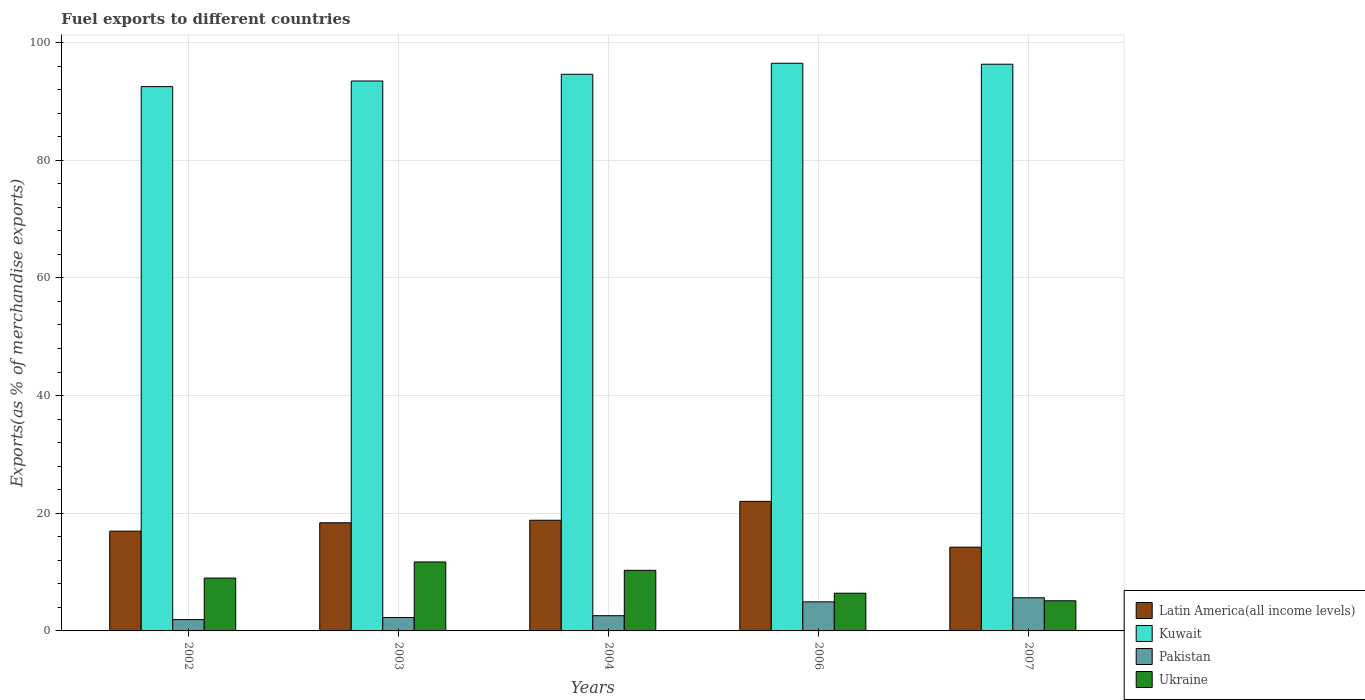How many groups of bars are there?
Make the answer very short. 5. How many bars are there on the 1st tick from the left?
Offer a very short reply. 4. How many bars are there on the 1st tick from the right?
Provide a short and direct response. 4. What is the percentage of exports to different countries in Ukraine in 2002?
Your answer should be very brief. 8.98. Across all years, what is the maximum percentage of exports to different countries in Latin America(all income levels)?
Offer a very short reply. 22.02. Across all years, what is the minimum percentage of exports to different countries in Pakistan?
Give a very brief answer. 1.93. In which year was the percentage of exports to different countries in Ukraine maximum?
Provide a short and direct response. 2003. In which year was the percentage of exports to different countries in Pakistan minimum?
Keep it short and to the point. 2002. What is the total percentage of exports to different countries in Pakistan in the graph?
Provide a short and direct response. 17.36. What is the difference between the percentage of exports to different countries in Latin America(all income levels) in 2004 and that in 2007?
Make the answer very short. 4.58. What is the difference between the percentage of exports to different countries in Latin America(all income levels) in 2007 and the percentage of exports to different countries in Ukraine in 2004?
Your answer should be very brief. 3.93. What is the average percentage of exports to different countries in Ukraine per year?
Provide a short and direct response. 8.51. In the year 2002, what is the difference between the percentage of exports to different countries in Latin America(all income levels) and percentage of exports to different countries in Kuwait?
Give a very brief answer. -75.54. In how many years, is the percentage of exports to different countries in Ukraine greater than 16 %?
Your answer should be compact. 0. What is the ratio of the percentage of exports to different countries in Latin America(all income levels) in 2002 to that in 2007?
Give a very brief answer. 1.19. Is the percentage of exports to different countries in Ukraine in 2004 less than that in 2007?
Offer a very short reply. No. What is the difference between the highest and the second highest percentage of exports to different countries in Ukraine?
Keep it short and to the point. 1.42. What is the difference between the highest and the lowest percentage of exports to different countries in Ukraine?
Your response must be concise. 6.6. In how many years, is the percentage of exports to different countries in Kuwait greater than the average percentage of exports to different countries in Kuwait taken over all years?
Your response must be concise. 2. Is the sum of the percentage of exports to different countries in Ukraine in 2003 and 2004 greater than the maximum percentage of exports to different countries in Pakistan across all years?
Your answer should be very brief. Yes. Is it the case that in every year, the sum of the percentage of exports to different countries in Latin America(all income levels) and percentage of exports to different countries in Kuwait is greater than the sum of percentage of exports to different countries in Ukraine and percentage of exports to different countries in Pakistan?
Your answer should be very brief. No. What does the 1st bar from the right in 2002 represents?
Your answer should be compact. Ukraine. Is it the case that in every year, the sum of the percentage of exports to different countries in Pakistan and percentage of exports to different countries in Ukraine is greater than the percentage of exports to different countries in Kuwait?
Offer a very short reply. No. Are all the bars in the graph horizontal?
Offer a terse response. No. What is the title of the graph?
Give a very brief answer. Fuel exports to different countries. Does "Gambia, The" appear as one of the legend labels in the graph?
Offer a very short reply. No. What is the label or title of the Y-axis?
Offer a very short reply. Exports(as % of merchandise exports). What is the Exports(as % of merchandise exports) in Latin America(all income levels) in 2002?
Give a very brief answer. 16.95. What is the Exports(as % of merchandise exports) of Kuwait in 2002?
Give a very brief answer. 92.5. What is the Exports(as % of merchandise exports) of Pakistan in 2002?
Your answer should be compact. 1.93. What is the Exports(as % of merchandise exports) of Ukraine in 2002?
Your answer should be very brief. 8.98. What is the Exports(as % of merchandise exports) in Latin America(all income levels) in 2003?
Ensure brevity in your answer.  18.38. What is the Exports(as % of merchandise exports) of Kuwait in 2003?
Give a very brief answer. 93.46. What is the Exports(as % of merchandise exports) of Pakistan in 2003?
Offer a terse response. 2.28. What is the Exports(as % of merchandise exports) of Ukraine in 2003?
Offer a terse response. 11.72. What is the Exports(as % of merchandise exports) of Latin America(all income levels) in 2004?
Keep it short and to the point. 18.81. What is the Exports(as % of merchandise exports) in Kuwait in 2004?
Give a very brief answer. 94.6. What is the Exports(as % of merchandise exports) of Pakistan in 2004?
Make the answer very short. 2.59. What is the Exports(as % of merchandise exports) in Ukraine in 2004?
Your answer should be very brief. 10.3. What is the Exports(as % of merchandise exports) of Latin America(all income levels) in 2006?
Your answer should be compact. 22.02. What is the Exports(as % of merchandise exports) in Kuwait in 2006?
Your response must be concise. 96.47. What is the Exports(as % of merchandise exports) of Pakistan in 2006?
Offer a terse response. 4.94. What is the Exports(as % of merchandise exports) of Ukraine in 2006?
Keep it short and to the point. 6.41. What is the Exports(as % of merchandise exports) in Latin America(all income levels) in 2007?
Give a very brief answer. 14.23. What is the Exports(as % of merchandise exports) of Kuwait in 2007?
Your answer should be very brief. 96.31. What is the Exports(as % of merchandise exports) of Pakistan in 2007?
Ensure brevity in your answer.  5.63. What is the Exports(as % of merchandise exports) of Ukraine in 2007?
Ensure brevity in your answer.  5.12. Across all years, what is the maximum Exports(as % of merchandise exports) in Latin America(all income levels)?
Ensure brevity in your answer.  22.02. Across all years, what is the maximum Exports(as % of merchandise exports) of Kuwait?
Your response must be concise. 96.47. Across all years, what is the maximum Exports(as % of merchandise exports) of Pakistan?
Offer a terse response. 5.63. Across all years, what is the maximum Exports(as % of merchandise exports) of Ukraine?
Your response must be concise. 11.72. Across all years, what is the minimum Exports(as % of merchandise exports) in Latin America(all income levels)?
Keep it short and to the point. 14.23. Across all years, what is the minimum Exports(as % of merchandise exports) of Kuwait?
Offer a terse response. 92.5. Across all years, what is the minimum Exports(as % of merchandise exports) of Pakistan?
Keep it short and to the point. 1.93. Across all years, what is the minimum Exports(as % of merchandise exports) of Ukraine?
Your answer should be very brief. 5.12. What is the total Exports(as % of merchandise exports) of Latin America(all income levels) in the graph?
Provide a short and direct response. 90.39. What is the total Exports(as % of merchandise exports) in Kuwait in the graph?
Offer a very short reply. 473.33. What is the total Exports(as % of merchandise exports) of Pakistan in the graph?
Ensure brevity in your answer.  17.36. What is the total Exports(as % of merchandise exports) of Ukraine in the graph?
Provide a succinct answer. 42.54. What is the difference between the Exports(as % of merchandise exports) of Latin America(all income levels) in 2002 and that in 2003?
Keep it short and to the point. -1.43. What is the difference between the Exports(as % of merchandise exports) in Kuwait in 2002 and that in 2003?
Provide a short and direct response. -0.96. What is the difference between the Exports(as % of merchandise exports) of Pakistan in 2002 and that in 2003?
Give a very brief answer. -0.35. What is the difference between the Exports(as % of merchandise exports) in Ukraine in 2002 and that in 2003?
Offer a very short reply. -2.74. What is the difference between the Exports(as % of merchandise exports) in Latin America(all income levels) in 2002 and that in 2004?
Your answer should be very brief. -1.85. What is the difference between the Exports(as % of merchandise exports) of Kuwait in 2002 and that in 2004?
Keep it short and to the point. -2.1. What is the difference between the Exports(as % of merchandise exports) of Pakistan in 2002 and that in 2004?
Your answer should be compact. -0.66. What is the difference between the Exports(as % of merchandise exports) in Ukraine in 2002 and that in 2004?
Your answer should be compact. -1.32. What is the difference between the Exports(as % of merchandise exports) of Latin America(all income levels) in 2002 and that in 2006?
Make the answer very short. -5.06. What is the difference between the Exports(as % of merchandise exports) in Kuwait in 2002 and that in 2006?
Ensure brevity in your answer.  -3.97. What is the difference between the Exports(as % of merchandise exports) of Pakistan in 2002 and that in 2006?
Give a very brief answer. -3.01. What is the difference between the Exports(as % of merchandise exports) of Ukraine in 2002 and that in 2006?
Offer a terse response. 2.57. What is the difference between the Exports(as % of merchandise exports) of Latin America(all income levels) in 2002 and that in 2007?
Provide a succinct answer. 2.73. What is the difference between the Exports(as % of merchandise exports) in Kuwait in 2002 and that in 2007?
Offer a very short reply. -3.81. What is the difference between the Exports(as % of merchandise exports) of Pakistan in 2002 and that in 2007?
Give a very brief answer. -3.71. What is the difference between the Exports(as % of merchandise exports) in Ukraine in 2002 and that in 2007?
Your response must be concise. 3.86. What is the difference between the Exports(as % of merchandise exports) in Latin America(all income levels) in 2003 and that in 2004?
Offer a very short reply. -0.43. What is the difference between the Exports(as % of merchandise exports) in Kuwait in 2003 and that in 2004?
Offer a terse response. -1.14. What is the difference between the Exports(as % of merchandise exports) of Pakistan in 2003 and that in 2004?
Ensure brevity in your answer.  -0.31. What is the difference between the Exports(as % of merchandise exports) in Ukraine in 2003 and that in 2004?
Provide a short and direct response. 1.42. What is the difference between the Exports(as % of merchandise exports) of Latin America(all income levels) in 2003 and that in 2006?
Ensure brevity in your answer.  -3.64. What is the difference between the Exports(as % of merchandise exports) of Kuwait in 2003 and that in 2006?
Provide a short and direct response. -3.01. What is the difference between the Exports(as % of merchandise exports) of Pakistan in 2003 and that in 2006?
Offer a terse response. -2.66. What is the difference between the Exports(as % of merchandise exports) of Ukraine in 2003 and that in 2006?
Keep it short and to the point. 5.31. What is the difference between the Exports(as % of merchandise exports) of Latin America(all income levels) in 2003 and that in 2007?
Ensure brevity in your answer.  4.15. What is the difference between the Exports(as % of merchandise exports) in Kuwait in 2003 and that in 2007?
Your answer should be compact. -2.85. What is the difference between the Exports(as % of merchandise exports) of Pakistan in 2003 and that in 2007?
Offer a very short reply. -3.35. What is the difference between the Exports(as % of merchandise exports) of Ukraine in 2003 and that in 2007?
Offer a terse response. 6.6. What is the difference between the Exports(as % of merchandise exports) of Latin America(all income levels) in 2004 and that in 2006?
Keep it short and to the point. -3.21. What is the difference between the Exports(as % of merchandise exports) in Kuwait in 2004 and that in 2006?
Your response must be concise. -1.87. What is the difference between the Exports(as % of merchandise exports) of Pakistan in 2004 and that in 2006?
Your answer should be very brief. -2.36. What is the difference between the Exports(as % of merchandise exports) in Ukraine in 2004 and that in 2006?
Offer a very short reply. 3.89. What is the difference between the Exports(as % of merchandise exports) of Latin America(all income levels) in 2004 and that in 2007?
Provide a short and direct response. 4.58. What is the difference between the Exports(as % of merchandise exports) in Kuwait in 2004 and that in 2007?
Keep it short and to the point. -1.71. What is the difference between the Exports(as % of merchandise exports) of Pakistan in 2004 and that in 2007?
Offer a terse response. -3.05. What is the difference between the Exports(as % of merchandise exports) in Ukraine in 2004 and that in 2007?
Offer a very short reply. 5.18. What is the difference between the Exports(as % of merchandise exports) in Latin America(all income levels) in 2006 and that in 2007?
Make the answer very short. 7.79. What is the difference between the Exports(as % of merchandise exports) of Kuwait in 2006 and that in 2007?
Provide a short and direct response. 0.16. What is the difference between the Exports(as % of merchandise exports) of Pakistan in 2006 and that in 2007?
Provide a short and direct response. -0.69. What is the difference between the Exports(as % of merchandise exports) in Ukraine in 2006 and that in 2007?
Keep it short and to the point. 1.29. What is the difference between the Exports(as % of merchandise exports) of Latin America(all income levels) in 2002 and the Exports(as % of merchandise exports) of Kuwait in 2003?
Offer a terse response. -76.5. What is the difference between the Exports(as % of merchandise exports) in Latin America(all income levels) in 2002 and the Exports(as % of merchandise exports) in Pakistan in 2003?
Your answer should be compact. 14.68. What is the difference between the Exports(as % of merchandise exports) of Latin America(all income levels) in 2002 and the Exports(as % of merchandise exports) of Ukraine in 2003?
Your answer should be very brief. 5.23. What is the difference between the Exports(as % of merchandise exports) in Kuwait in 2002 and the Exports(as % of merchandise exports) in Pakistan in 2003?
Make the answer very short. 90.22. What is the difference between the Exports(as % of merchandise exports) of Kuwait in 2002 and the Exports(as % of merchandise exports) of Ukraine in 2003?
Your response must be concise. 80.78. What is the difference between the Exports(as % of merchandise exports) in Pakistan in 2002 and the Exports(as % of merchandise exports) in Ukraine in 2003?
Make the answer very short. -9.8. What is the difference between the Exports(as % of merchandise exports) of Latin America(all income levels) in 2002 and the Exports(as % of merchandise exports) of Kuwait in 2004?
Offer a terse response. -77.64. What is the difference between the Exports(as % of merchandise exports) in Latin America(all income levels) in 2002 and the Exports(as % of merchandise exports) in Pakistan in 2004?
Make the answer very short. 14.37. What is the difference between the Exports(as % of merchandise exports) of Latin America(all income levels) in 2002 and the Exports(as % of merchandise exports) of Ukraine in 2004?
Provide a short and direct response. 6.66. What is the difference between the Exports(as % of merchandise exports) in Kuwait in 2002 and the Exports(as % of merchandise exports) in Pakistan in 2004?
Ensure brevity in your answer.  89.91. What is the difference between the Exports(as % of merchandise exports) in Kuwait in 2002 and the Exports(as % of merchandise exports) in Ukraine in 2004?
Give a very brief answer. 82.2. What is the difference between the Exports(as % of merchandise exports) in Pakistan in 2002 and the Exports(as % of merchandise exports) in Ukraine in 2004?
Provide a short and direct response. -8.37. What is the difference between the Exports(as % of merchandise exports) of Latin America(all income levels) in 2002 and the Exports(as % of merchandise exports) of Kuwait in 2006?
Offer a terse response. -79.52. What is the difference between the Exports(as % of merchandise exports) in Latin America(all income levels) in 2002 and the Exports(as % of merchandise exports) in Pakistan in 2006?
Provide a succinct answer. 12.01. What is the difference between the Exports(as % of merchandise exports) in Latin America(all income levels) in 2002 and the Exports(as % of merchandise exports) in Ukraine in 2006?
Your answer should be very brief. 10.55. What is the difference between the Exports(as % of merchandise exports) in Kuwait in 2002 and the Exports(as % of merchandise exports) in Pakistan in 2006?
Offer a terse response. 87.56. What is the difference between the Exports(as % of merchandise exports) of Kuwait in 2002 and the Exports(as % of merchandise exports) of Ukraine in 2006?
Offer a very short reply. 86.09. What is the difference between the Exports(as % of merchandise exports) of Pakistan in 2002 and the Exports(as % of merchandise exports) of Ukraine in 2006?
Your response must be concise. -4.48. What is the difference between the Exports(as % of merchandise exports) in Latin America(all income levels) in 2002 and the Exports(as % of merchandise exports) in Kuwait in 2007?
Ensure brevity in your answer.  -79.35. What is the difference between the Exports(as % of merchandise exports) in Latin America(all income levels) in 2002 and the Exports(as % of merchandise exports) in Pakistan in 2007?
Your answer should be compact. 11.32. What is the difference between the Exports(as % of merchandise exports) of Latin America(all income levels) in 2002 and the Exports(as % of merchandise exports) of Ukraine in 2007?
Give a very brief answer. 11.83. What is the difference between the Exports(as % of merchandise exports) of Kuwait in 2002 and the Exports(as % of merchandise exports) of Pakistan in 2007?
Your answer should be compact. 86.87. What is the difference between the Exports(as % of merchandise exports) in Kuwait in 2002 and the Exports(as % of merchandise exports) in Ukraine in 2007?
Provide a succinct answer. 87.38. What is the difference between the Exports(as % of merchandise exports) of Pakistan in 2002 and the Exports(as % of merchandise exports) of Ukraine in 2007?
Offer a terse response. -3.2. What is the difference between the Exports(as % of merchandise exports) of Latin America(all income levels) in 2003 and the Exports(as % of merchandise exports) of Kuwait in 2004?
Offer a very short reply. -76.22. What is the difference between the Exports(as % of merchandise exports) in Latin America(all income levels) in 2003 and the Exports(as % of merchandise exports) in Pakistan in 2004?
Make the answer very short. 15.79. What is the difference between the Exports(as % of merchandise exports) in Latin America(all income levels) in 2003 and the Exports(as % of merchandise exports) in Ukraine in 2004?
Your answer should be compact. 8.08. What is the difference between the Exports(as % of merchandise exports) in Kuwait in 2003 and the Exports(as % of merchandise exports) in Pakistan in 2004?
Keep it short and to the point. 90.87. What is the difference between the Exports(as % of merchandise exports) in Kuwait in 2003 and the Exports(as % of merchandise exports) in Ukraine in 2004?
Offer a terse response. 83.16. What is the difference between the Exports(as % of merchandise exports) of Pakistan in 2003 and the Exports(as % of merchandise exports) of Ukraine in 2004?
Keep it short and to the point. -8.02. What is the difference between the Exports(as % of merchandise exports) in Latin America(all income levels) in 2003 and the Exports(as % of merchandise exports) in Kuwait in 2006?
Your answer should be very brief. -78.09. What is the difference between the Exports(as % of merchandise exports) in Latin America(all income levels) in 2003 and the Exports(as % of merchandise exports) in Pakistan in 2006?
Your response must be concise. 13.44. What is the difference between the Exports(as % of merchandise exports) in Latin America(all income levels) in 2003 and the Exports(as % of merchandise exports) in Ukraine in 2006?
Make the answer very short. 11.97. What is the difference between the Exports(as % of merchandise exports) in Kuwait in 2003 and the Exports(as % of merchandise exports) in Pakistan in 2006?
Your answer should be compact. 88.52. What is the difference between the Exports(as % of merchandise exports) of Kuwait in 2003 and the Exports(as % of merchandise exports) of Ukraine in 2006?
Provide a succinct answer. 87.05. What is the difference between the Exports(as % of merchandise exports) of Pakistan in 2003 and the Exports(as % of merchandise exports) of Ukraine in 2006?
Keep it short and to the point. -4.13. What is the difference between the Exports(as % of merchandise exports) of Latin America(all income levels) in 2003 and the Exports(as % of merchandise exports) of Kuwait in 2007?
Provide a succinct answer. -77.93. What is the difference between the Exports(as % of merchandise exports) of Latin America(all income levels) in 2003 and the Exports(as % of merchandise exports) of Pakistan in 2007?
Your answer should be very brief. 12.75. What is the difference between the Exports(as % of merchandise exports) of Latin America(all income levels) in 2003 and the Exports(as % of merchandise exports) of Ukraine in 2007?
Provide a succinct answer. 13.26. What is the difference between the Exports(as % of merchandise exports) in Kuwait in 2003 and the Exports(as % of merchandise exports) in Pakistan in 2007?
Provide a succinct answer. 87.82. What is the difference between the Exports(as % of merchandise exports) of Kuwait in 2003 and the Exports(as % of merchandise exports) of Ukraine in 2007?
Keep it short and to the point. 88.33. What is the difference between the Exports(as % of merchandise exports) of Pakistan in 2003 and the Exports(as % of merchandise exports) of Ukraine in 2007?
Your answer should be very brief. -2.84. What is the difference between the Exports(as % of merchandise exports) in Latin America(all income levels) in 2004 and the Exports(as % of merchandise exports) in Kuwait in 2006?
Provide a short and direct response. -77.66. What is the difference between the Exports(as % of merchandise exports) in Latin America(all income levels) in 2004 and the Exports(as % of merchandise exports) in Pakistan in 2006?
Make the answer very short. 13.87. What is the difference between the Exports(as % of merchandise exports) in Latin America(all income levels) in 2004 and the Exports(as % of merchandise exports) in Ukraine in 2006?
Keep it short and to the point. 12.4. What is the difference between the Exports(as % of merchandise exports) of Kuwait in 2004 and the Exports(as % of merchandise exports) of Pakistan in 2006?
Ensure brevity in your answer.  89.66. What is the difference between the Exports(as % of merchandise exports) in Kuwait in 2004 and the Exports(as % of merchandise exports) in Ukraine in 2006?
Give a very brief answer. 88.19. What is the difference between the Exports(as % of merchandise exports) in Pakistan in 2004 and the Exports(as % of merchandise exports) in Ukraine in 2006?
Offer a terse response. -3.82. What is the difference between the Exports(as % of merchandise exports) in Latin America(all income levels) in 2004 and the Exports(as % of merchandise exports) in Kuwait in 2007?
Ensure brevity in your answer.  -77.5. What is the difference between the Exports(as % of merchandise exports) in Latin America(all income levels) in 2004 and the Exports(as % of merchandise exports) in Pakistan in 2007?
Give a very brief answer. 13.18. What is the difference between the Exports(as % of merchandise exports) in Latin America(all income levels) in 2004 and the Exports(as % of merchandise exports) in Ukraine in 2007?
Provide a succinct answer. 13.69. What is the difference between the Exports(as % of merchandise exports) of Kuwait in 2004 and the Exports(as % of merchandise exports) of Pakistan in 2007?
Your answer should be very brief. 88.97. What is the difference between the Exports(as % of merchandise exports) of Kuwait in 2004 and the Exports(as % of merchandise exports) of Ukraine in 2007?
Keep it short and to the point. 89.48. What is the difference between the Exports(as % of merchandise exports) in Pakistan in 2004 and the Exports(as % of merchandise exports) in Ukraine in 2007?
Offer a very short reply. -2.54. What is the difference between the Exports(as % of merchandise exports) in Latin America(all income levels) in 2006 and the Exports(as % of merchandise exports) in Kuwait in 2007?
Provide a short and direct response. -74.29. What is the difference between the Exports(as % of merchandise exports) in Latin America(all income levels) in 2006 and the Exports(as % of merchandise exports) in Pakistan in 2007?
Your answer should be very brief. 16.39. What is the difference between the Exports(as % of merchandise exports) of Latin America(all income levels) in 2006 and the Exports(as % of merchandise exports) of Ukraine in 2007?
Ensure brevity in your answer.  16.9. What is the difference between the Exports(as % of merchandise exports) of Kuwait in 2006 and the Exports(as % of merchandise exports) of Pakistan in 2007?
Offer a very short reply. 90.84. What is the difference between the Exports(as % of merchandise exports) in Kuwait in 2006 and the Exports(as % of merchandise exports) in Ukraine in 2007?
Your answer should be very brief. 91.35. What is the difference between the Exports(as % of merchandise exports) in Pakistan in 2006 and the Exports(as % of merchandise exports) in Ukraine in 2007?
Ensure brevity in your answer.  -0.18. What is the average Exports(as % of merchandise exports) of Latin America(all income levels) per year?
Ensure brevity in your answer.  18.08. What is the average Exports(as % of merchandise exports) in Kuwait per year?
Provide a short and direct response. 94.67. What is the average Exports(as % of merchandise exports) of Pakistan per year?
Offer a terse response. 3.47. What is the average Exports(as % of merchandise exports) in Ukraine per year?
Keep it short and to the point. 8.51. In the year 2002, what is the difference between the Exports(as % of merchandise exports) of Latin America(all income levels) and Exports(as % of merchandise exports) of Kuwait?
Offer a terse response. -75.54. In the year 2002, what is the difference between the Exports(as % of merchandise exports) of Latin America(all income levels) and Exports(as % of merchandise exports) of Pakistan?
Ensure brevity in your answer.  15.03. In the year 2002, what is the difference between the Exports(as % of merchandise exports) of Latin America(all income levels) and Exports(as % of merchandise exports) of Ukraine?
Provide a short and direct response. 7.97. In the year 2002, what is the difference between the Exports(as % of merchandise exports) of Kuwait and Exports(as % of merchandise exports) of Pakistan?
Make the answer very short. 90.57. In the year 2002, what is the difference between the Exports(as % of merchandise exports) in Kuwait and Exports(as % of merchandise exports) in Ukraine?
Give a very brief answer. 83.52. In the year 2002, what is the difference between the Exports(as % of merchandise exports) in Pakistan and Exports(as % of merchandise exports) in Ukraine?
Make the answer very short. -7.05. In the year 2003, what is the difference between the Exports(as % of merchandise exports) in Latin America(all income levels) and Exports(as % of merchandise exports) in Kuwait?
Provide a short and direct response. -75.08. In the year 2003, what is the difference between the Exports(as % of merchandise exports) in Latin America(all income levels) and Exports(as % of merchandise exports) in Pakistan?
Ensure brevity in your answer.  16.1. In the year 2003, what is the difference between the Exports(as % of merchandise exports) of Latin America(all income levels) and Exports(as % of merchandise exports) of Ukraine?
Your answer should be compact. 6.66. In the year 2003, what is the difference between the Exports(as % of merchandise exports) of Kuwait and Exports(as % of merchandise exports) of Pakistan?
Your answer should be very brief. 91.18. In the year 2003, what is the difference between the Exports(as % of merchandise exports) of Kuwait and Exports(as % of merchandise exports) of Ukraine?
Offer a very short reply. 81.73. In the year 2003, what is the difference between the Exports(as % of merchandise exports) of Pakistan and Exports(as % of merchandise exports) of Ukraine?
Your response must be concise. -9.44. In the year 2004, what is the difference between the Exports(as % of merchandise exports) in Latin America(all income levels) and Exports(as % of merchandise exports) in Kuwait?
Provide a succinct answer. -75.79. In the year 2004, what is the difference between the Exports(as % of merchandise exports) in Latin America(all income levels) and Exports(as % of merchandise exports) in Pakistan?
Provide a short and direct response. 16.22. In the year 2004, what is the difference between the Exports(as % of merchandise exports) in Latin America(all income levels) and Exports(as % of merchandise exports) in Ukraine?
Your answer should be compact. 8.51. In the year 2004, what is the difference between the Exports(as % of merchandise exports) of Kuwait and Exports(as % of merchandise exports) of Pakistan?
Your answer should be compact. 92.01. In the year 2004, what is the difference between the Exports(as % of merchandise exports) in Kuwait and Exports(as % of merchandise exports) in Ukraine?
Give a very brief answer. 84.3. In the year 2004, what is the difference between the Exports(as % of merchandise exports) of Pakistan and Exports(as % of merchandise exports) of Ukraine?
Make the answer very short. -7.71. In the year 2006, what is the difference between the Exports(as % of merchandise exports) of Latin America(all income levels) and Exports(as % of merchandise exports) of Kuwait?
Your response must be concise. -74.45. In the year 2006, what is the difference between the Exports(as % of merchandise exports) of Latin America(all income levels) and Exports(as % of merchandise exports) of Pakistan?
Offer a terse response. 17.08. In the year 2006, what is the difference between the Exports(as % of merchandise exports) in Latin America(all income levels) and Exports(as % of merchandise exports) in Ukraine?
Your answer should be compact. 15.61. In the year 2006, what is the difference between the Exports(as % of merchandise exports) in Kuwait and Exports(as % of merchandise exports) in Pakistan?
Your answer should be very brief. 91.53. In the year 2006, what is the difference between the Exports(as % of merchandise exports) in Kuwait and Exports(as % of merchandise exports) in Ukraine?
Give a very brief answer. 90.06. In the year 2006, what is the difference between the Exports(as % of merchandise exports) in Pakistan and Exports(as % of merchandise exports) in Ukraine?
Offer a very short reply. -1.47. In the year 2007, what is the difference between the Exports(as % of merchandise exports) of Latin America(all income levels) and Exports(as % of merchandise exports) of Kuwait?
Offer a very short reply. -82.08. In the year 2007, what is the difference between the Exports(as % of merchandise exports) in Latin America(all income levels) and Exports(as % of merchandise exports) in Pakistan?
Make the answer very short. 8.6. In the year 2007, what is the difference between the Exports(as % of merchandise exports) of Latin America(all income levels) and Exports(as % of merchandise exports) of Ukraine?
Provide a succinct answer. 9.11. In the year 2007, what is the difference between the Exports(as % of merchandise exports) of Kuwait and Exports(as % of merchandise exports) of Pakistan?
Your response must be concise. 90.67. In the year 2007, what is the difference between the Exports(as % of merchandise exports) in Kuwait and Exports(as % of merchandise exports) in Ukraine?
Your response must be concise. 91.18. In the year 2007, what is the difference between the Exports(as % of merchandise exports) of Pakistan and Exports(as % of merchandise exports) of Ukraine?
Keep it short and to the point. 0.51. What is the ratio of the Exports(as % of merchandise exports) of Latin America(all income levels) in 2002 to that in 2003?
Your answer should be very brief. 0.92. What is the ratio of the Exports(as % of merchandise exports) of Pakistan in 2002 to that in 2003?
Your answer should be very brief. 0.85. What is the ratio of the Exports(as % of merchandise exports) of Ukraine in 2002 to that in 2003?
Provide a short and direct response. 0.77. What is the ratio of the Exports(as % of merchandise exports) of Latin America(all income levels) in 2002 to that in 2004?
Offer a very short reply. 0.9. What is the ratio of the Exports(as % of merchandise exports) in Kuwait in 2002 to that in 2004?
Ensure brevity in your answer.  0.98. What is the ratio of the Exports(as % of merchandise exports) in Pakistan in 2002 to that in 2004?
Offer a very short reply. 0.75. What is the ratio of the Exports(as % of merchandise exports) in Ukraine in 2002 to that in 2004?
Keep it short and to the point. 0.87. What is the ratio of the Exports(as % of merchandise exports) of Latin America(all income levels) in 2002 to that in 2006?
Keep it short and to the point. 0.77. What is the ratio of the Exports(as % of merchandise exports) of Kuwait in 2002 to that in 2006?
Provide a short and direct response. 0.96. What is the ratio of the Exports(as % of merchandise exports) of Pakistan in 2002 to that in 2006?
Offer a very short reply. 0.39. What is the ratio of the Exports(as % of merchandise exports) in Ukraine in 2002 to that in 2006?
Provide a succinct answer. 1.4. What is the ratio of the Exports(as % of merchandise exports) of Latin America(all income levels) in 2002 to that in 2007?
Provide a succinct answer. 1.19. What is the ratio of the Exports(as % of merchandise exports) in Kuwait in 2002 to that in 2007?
Keep it short and to the point. 0.96. What is the ratio of the Exports(as % of merchandise exports) of Pakistan in 2002 to that in 2007?
Provide a succinct answer. 0.34. What is the ratio of the Exports(as % of merchandise exports) of Ukraine in 2002 to that in 2007?
Your response must be concise. 1.75. What is the ratio of the Exports(as % of merchandise exports) of Latin America(all income levels) in 2003 to that in 2004?
Offer a terse response. 0.98. What is the ratio of the Exports(as % of merchandise exports) of Kuwait in 2003 to that in 2004?
Offer a terse response. 0.99. What is the ratio of the Exports(as % of merchandise exports) of Pakistan in 2003 to that in 2004?
Keep it short and to the point. 0.88. What is the ratio of the Exports(as % of merchandise exports) in Ukraine in 2003 to that in 2004?
Make the answer very short. 1.14. What is the ratio of the Exports(as % of merchandise exports) of Latin America(all income levels) in 2003 to that in 2006?
Give a very brief answer. 0.83. What is the ratio of the Exports(as % of merchandise exports) in Kuwait in 2003 to that in 2006?
Make the answer very short. 0.97. What is the ratio of the Exports(as % of merchandise exports) of Pakistan in 2003 to that in 2006?
Your answer should be compact. 0.46. What is the ratio of the Exports(as % of merchandise exports) of Ukraine in 2003 to that in 2006?
Your answer should be compact. 1.83. What is the ratio of the Exports(as % of merchandise exports) in Latin America(all income levels) in 2003 to that in 2007?
Keep it short and to the point. 1.29. What is the ratio of the Exports(as % of merchandise exports) of Kuwait in 2003 to that in 2007?
Provide a short and direct response. 0.97. What is the ratio of the Exports(as % of merchandise exports) in Pakistan in 2003 to that in 2007?
Provide a short and direct response. 0.4. What is the ratio of the Exports(as % of merchandise exports) in Ukraine in 2003 to that in 2007?
Ensure brevity in your answer.  2.29. What is the ratio of the Exports(as % of merchandise exports) in Latin America(all income levels) in 2004 to that in 2006?
Offer a terse response. 0.85. What is the ratio of the Exports(as % of merchandise exports) in Kuwait in 2004 to that in 2006?
Offer a terse response. 0.98. What is the ratio of the Exports(as % of merchandise exports) of Pakistan in 2004 to that in 2006?
Your answer should be very brief. 0.52. What is the ratio of the Exports(as % of merchandise exports) in Ukraine in 2004 to that in 2006?
Keep it short and to the point. 1.61. What is the ratio of the Exports(as % of merchandise exports) in Latin America(all income levels) in 2004 to that in 2007?
Make the answer very short. 1.32. What is the ratio of the Exports(as % of merchandise exports) in Kuwait in 2004 to that in 2007?
Offer a very short reply. 0.98. What is the ratio of the Exports(as % of merchandise exports) of Pakistan in 2004 to that in 2007?
Ensure brevity in your answer.  0.46. What is the ratio of the Exports(as % of merchandise exports) of Ukraine in 2004 to that in 2007?
Provide a short and direct response. 2.01. What is the ratio of the Exports(as % of merchandise exports) of Latin America(all income levels) in 2006 to that in 2007?
Provide a succinct answer. 1.55. What is the ratio of the Exports(as % of merchandise exports) in Kuwait in 2006 to that in 2007?
Provide a succinct answer. 1. What is the ratio of the Exports(as % of merchandise exports) in Pakistan in 2006 to that in 2007?
Ensure brevity in your answer.  0.88. What is the ratio of the Exports(as % of merchandise exports) in Ukraine in 2006 to that in 2007?
Your answer should be compact. 1.25. What is the difference between the highest and the second highest Exports(as % of merchandise exports) in Latin America(all income levels)?
Keep it short and to the point. 3.21. What is the difference between the highest and the second highest Exports(as % of merchandise exports) in Kuwait?
Keep it short and to the point. 0.16. What is the difference between the highest and the second highest Exports(as % of merchandise exports) of Pakistan?
Keep it short and to the point. 0.69. What is the difference between the highest and the second highest Exports(as % of merchandise exports) of Ukraine?
Your answer should be very brief. 1.42. What is the difference between the highest and the lowest Exports(as % of merchandise exports) in Latin America(all income levels)?
Your answer should be very brief. 7.79. What is the difference between the highest and the lowest Exports(as % of merchandise exports) in Kuwait?
Provide a short and direct response. 3.97. What is the difference between the highest and the lowest Exports(as % of merchandise exports) of Pakistan?
Your answer should be very brief. 3.71. What is the difference between the highest and the lowest Exports(as % of merchandise exports) of Ukraine?
Your answer should be compact. 6.6. 